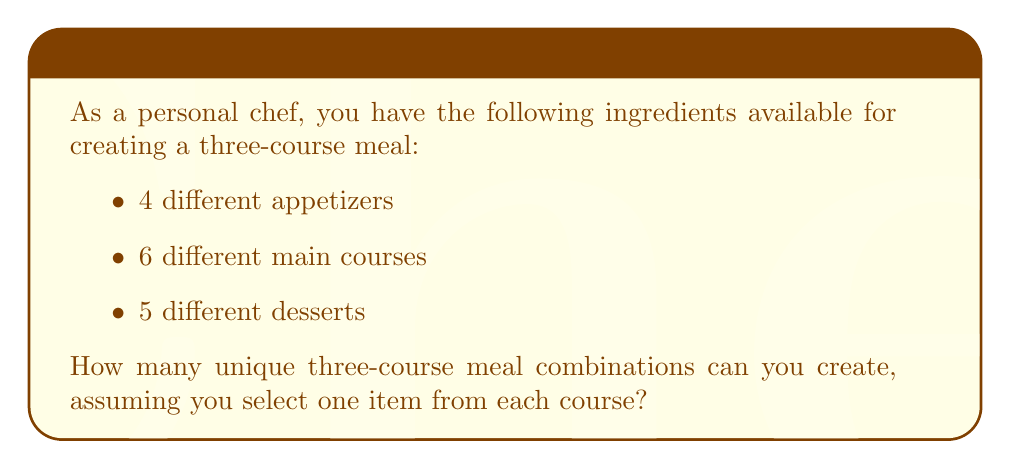Provide a solution to this math problem. To solve this problem, we'll use the multiplication principle of counting. This principle states that if we have a sequence of choices, and each choice is independent of the others, we multiply the number of options for each choice to get the total number of possible outcomes.

In this case, we have three independent choices:
1. Choosing an appetizer
2. Choosing a main course
3. Choosing a dessert

Let's break it down:
1. For the appetizer, we have 4 options.
2. For the main course, we have 6 options.
3. For the dessert, we have 5 options.

To calculate the total number of possible meal combinations, we multiply these numbers together:

$$ \text{Total combinations} = \text{Appetizer options} \times \text{Main course options} \times \text{Dessert options} $$

$$ \text{Total combinations} = 4 \times 6 \times 5 $$

$$ \text{Total combinations} = 120 $$

Therefore, the personal chef can create 120 unique three-course meal combinations using the available ingredients.
Answer: 120 unique meal combinations 